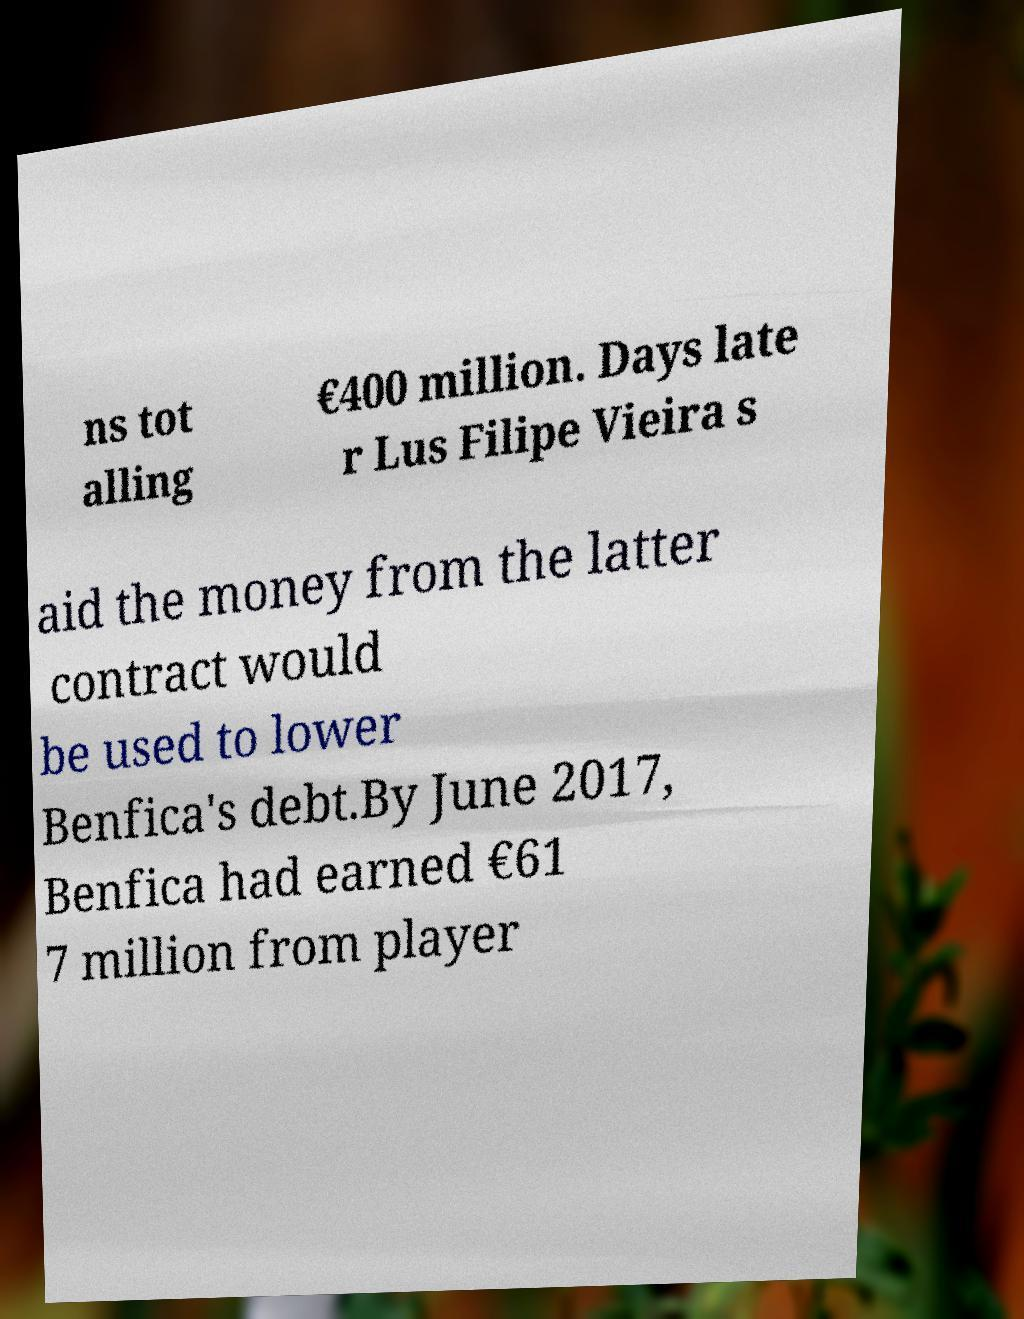Please identify and transcribe the text found in this image. ns tot alling €400 million. Days late r Lus Filipe Vieira s aid the money from the latter contract would be used to lower Benfica's debt.By June 2017, Benfica had earned €61 7 million from player 